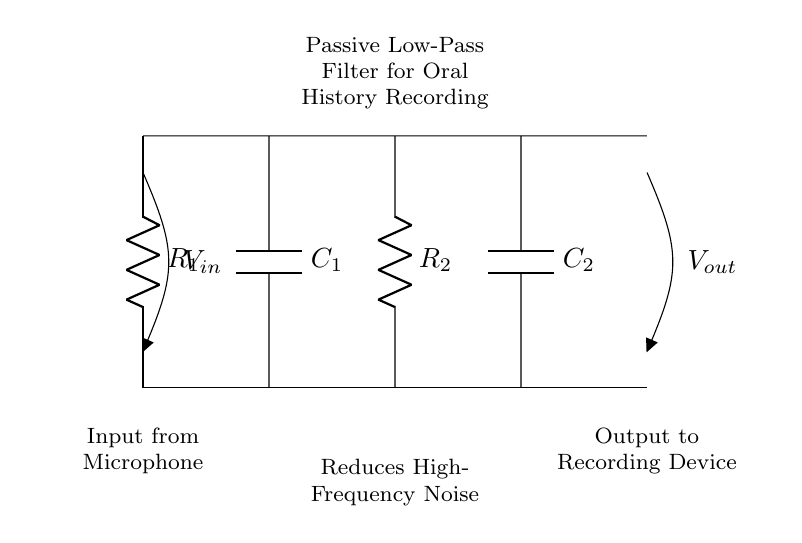What type of filter is represented in this circuit? The circuit is a passive low-pass filter, which can be inferred from the combination of resistors and capacitors designed to allow low-frequency signals to pass while attenuating higher frequencies.
Answer: Low-pass filter What is the purpose of the capacitors in this circuit? The capacitors serve to block high-frequency signals while allowing lower frequency signals to pass through, thus filtering out unwanted noise during recording.
Answer: Noise reduction What components are used in this passive filter? The circuit consists of two resistors and two capacitors, specifically labeled R1, R2, C1, and C2.
Answer: Two resistors and two capacitors Where is the input voltage applied in this circuit? The input voltage is applied at the top left of the circuit, indicated as V in, which is connected to the first resistor R1.
Answer: At V in What happens to high-frequency noise in this circuit? High-frequency noise is attenuated or reduced by the interaction between the resistors and capacitors, leading to a cleaner output signal being sent to the recording device.
Answer: Attenuated What is the output of this filter connected to? The output is connected to the recording device, as indicated by the label V out on the right side of the circuit.
Answer: Recording device 